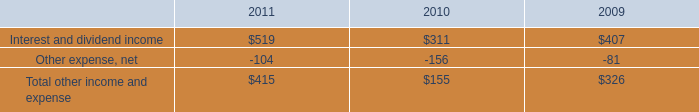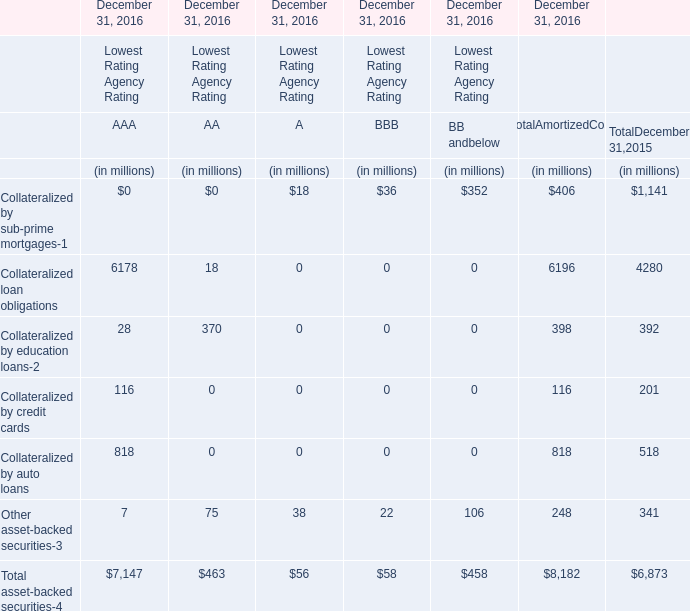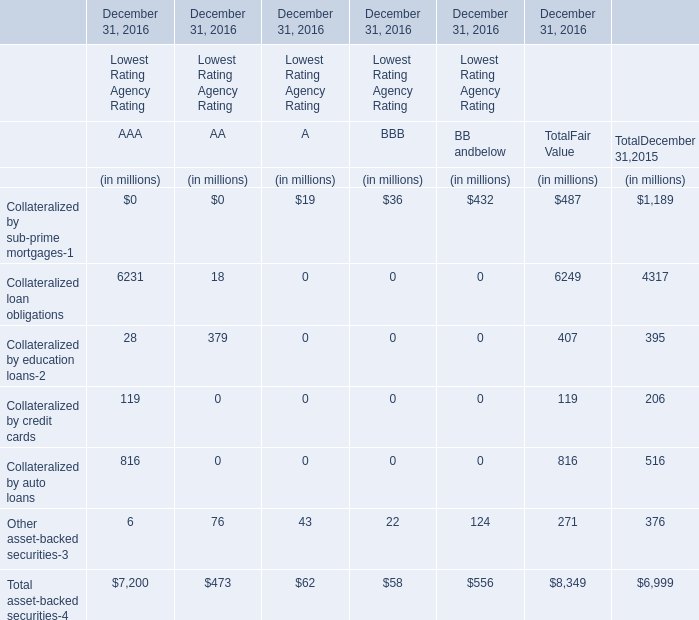What is the difference between the greatest Collateralized loan obligations in AAA and AA? (in million) 
Computations: (6231 - 18)
Answer: 6213.0. 